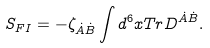Convert formula to latex. <formula><loc_0><loc_0><loc_500><loc_500>S _ { F I } = - \zeta _ { \dot { A } \dot { B } } \int d ^ { 6 } x T r D ^ { \dot { A } \dot { B } } .</formula> 